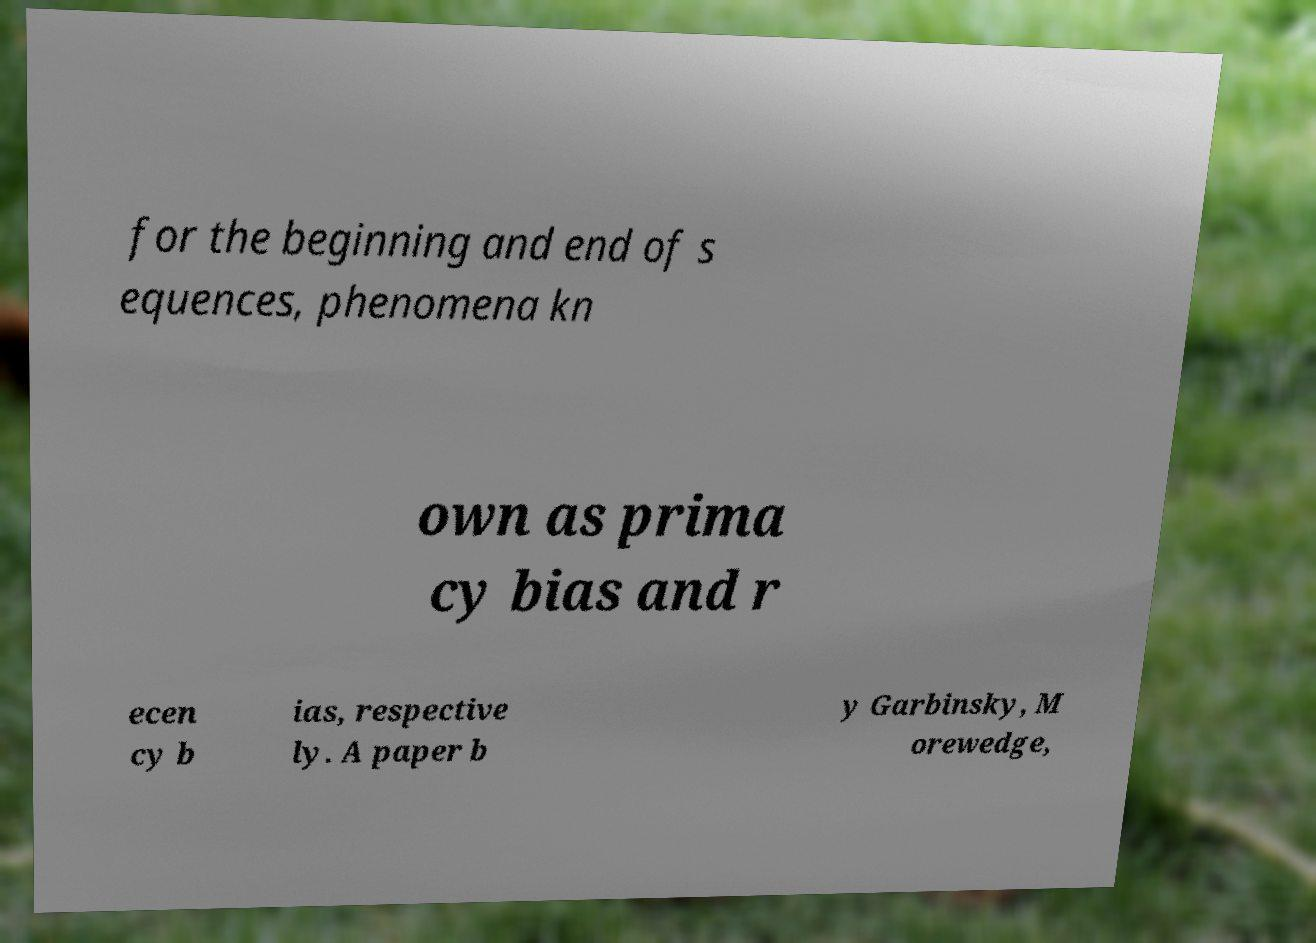I need the written content from this picture converted into text. Can you do that? for the beginning and end of s equences, phenomena kn own as prima cy bias and r ecen cy b ias, respective ly. A paper b y Garbinsky, M orewedge, 